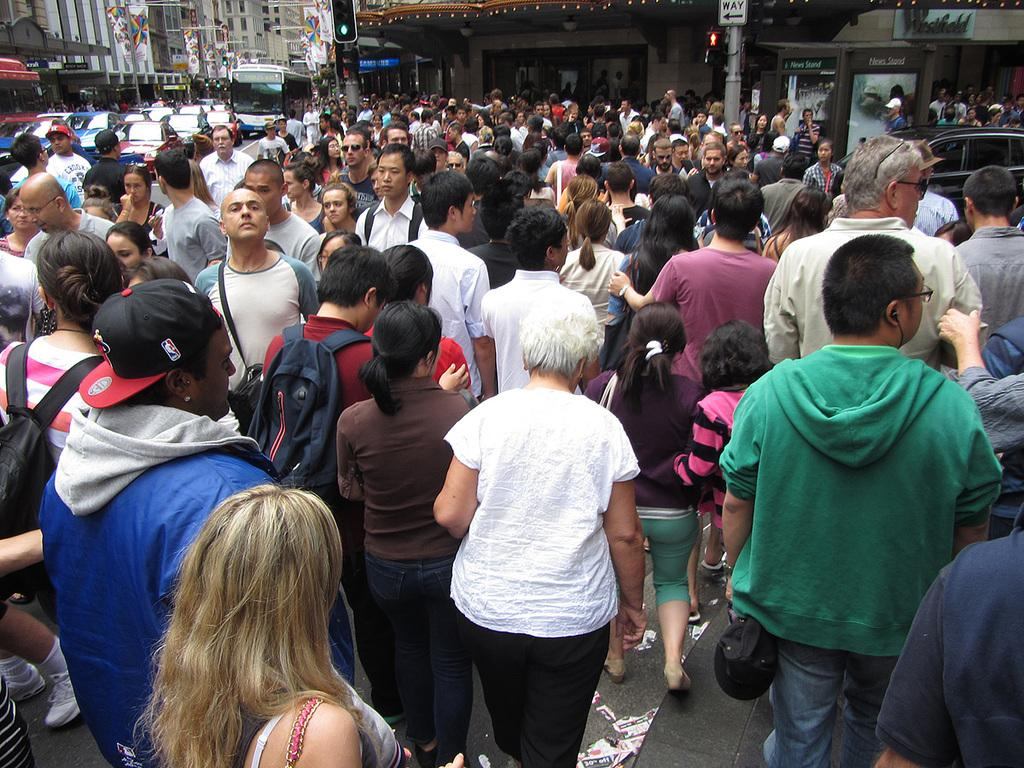What is the main subject of the image? The main subject of the image is a huge crowd of people. What are the people in the image doing? The people are standing and walking on the road. What can be seen in the image besides the crowd of people? There are signals, poles, cars, other vehicles, and buildings in the image. What is the argument about between the people in the image? There is no argument present in the image; it features a crowd of people standing and walking on the road. What type of debt is being discussed by the people in the image? There is no discussion of debt in the image; it focuses on a crowd of people and their surroundings. 